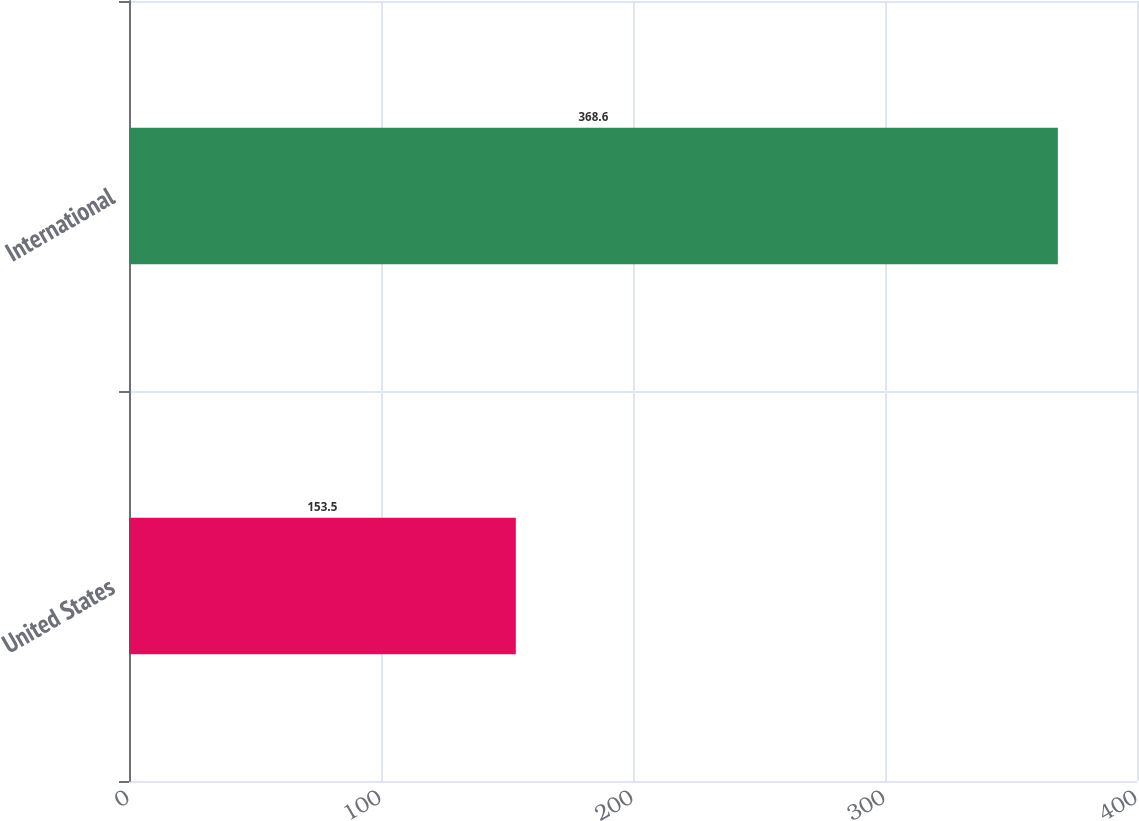Convert chart. <chart><loc_0><loc_0><loc_500><loc_500><bar_chart><fcel>United States<fcel>International<nl><fcel>153.5<fcel>368.6<nl></chart> 